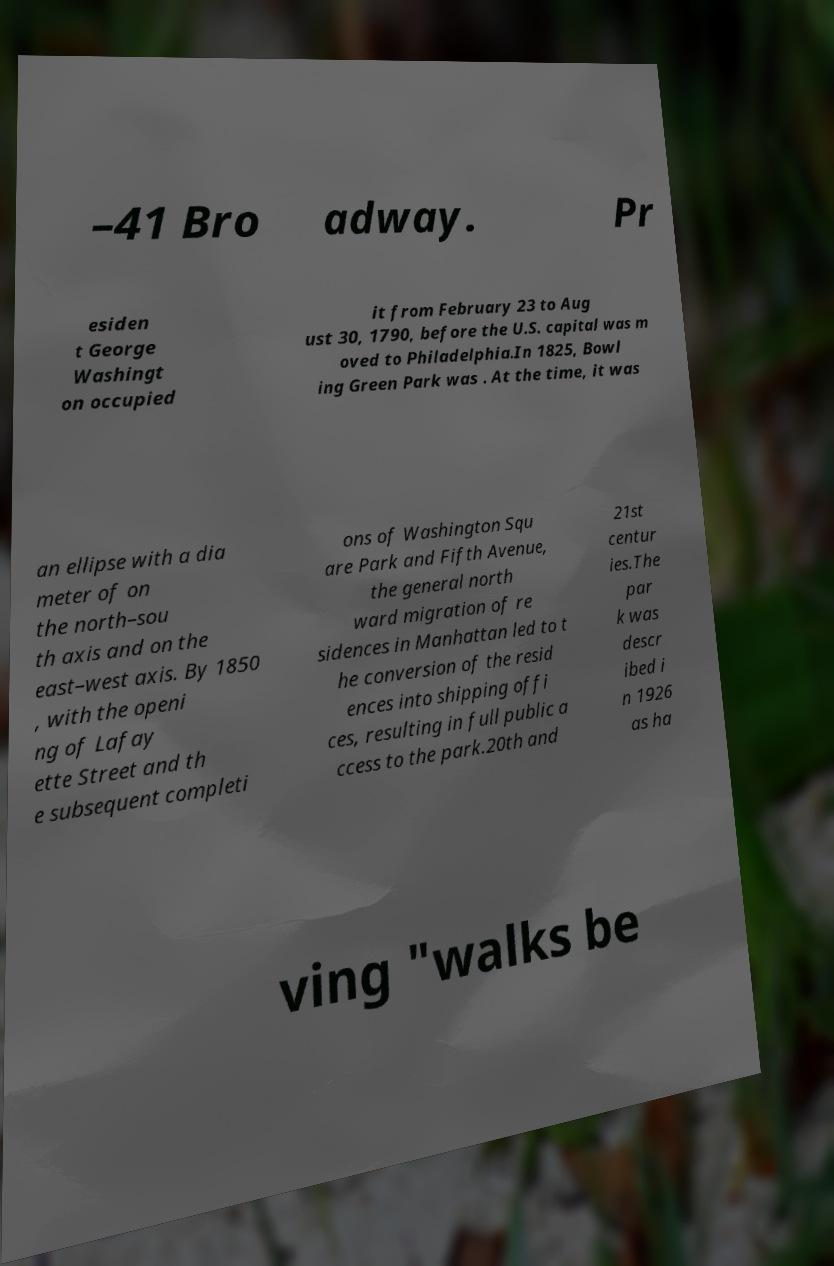Can you accurately transcribe the text from the provided image for me? –41 Bro adway. Pr esiden t George Washingt on occupied it from February 23 to Aug ust 30, 1790, before the U.S. capital was m oved to Philadelphia.In 1825, Bowl ing Green Park was . At the time, it was an ellipse with a dia meter of on the north–sou th axis and on the east–west axis. By 1850 , with the openi ng of Lafay ette Street and th e subsequent completi ons of Washington Squ are Park and Fifth Avenue, the general north ward migration of re sidences in Manhattan led to t he conversion of the resid ences into shipping offi ces, resulting in full public a ccess to the park.20th and 21st centur ies.The par k was descr ibed i n 1926 as ha ving "walks be 